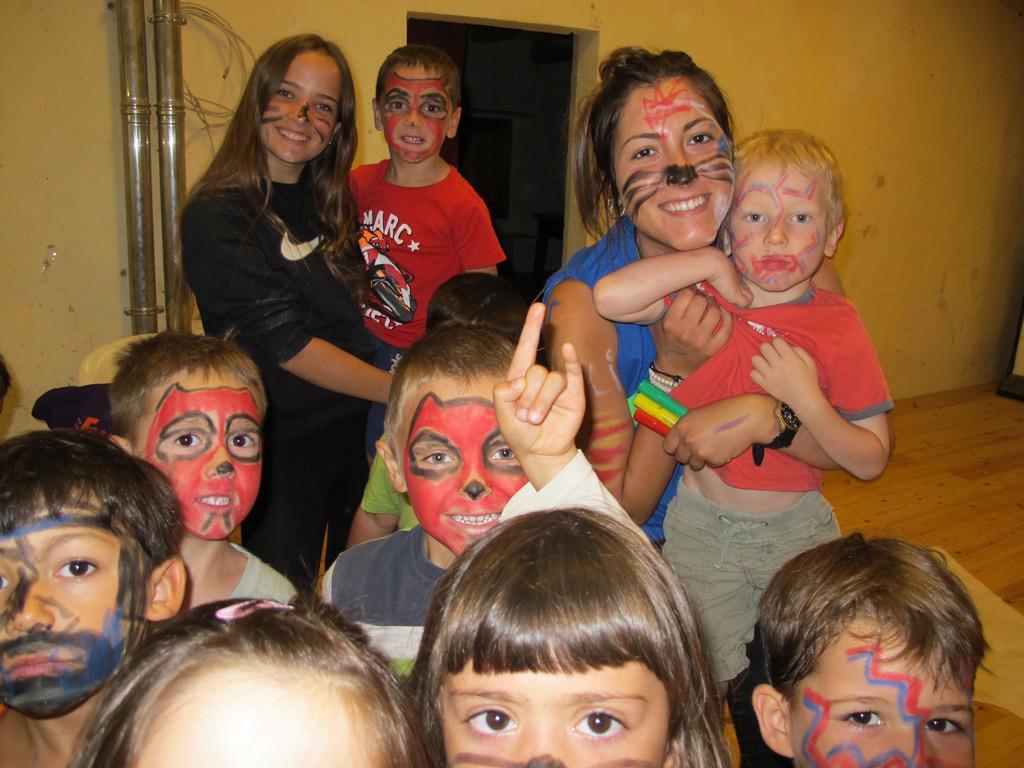In one or two sentences, can you explain what this image depicts? In this picture I can see the women who are standing near to the children. In the back I can see the pipe and door. 